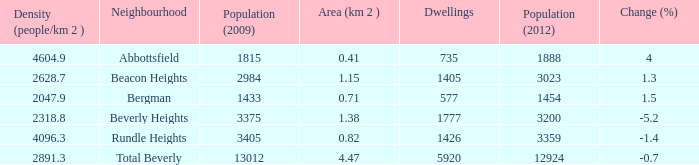What is the density of an area that is 1.38km and has a population more than 12924? 0.0. 